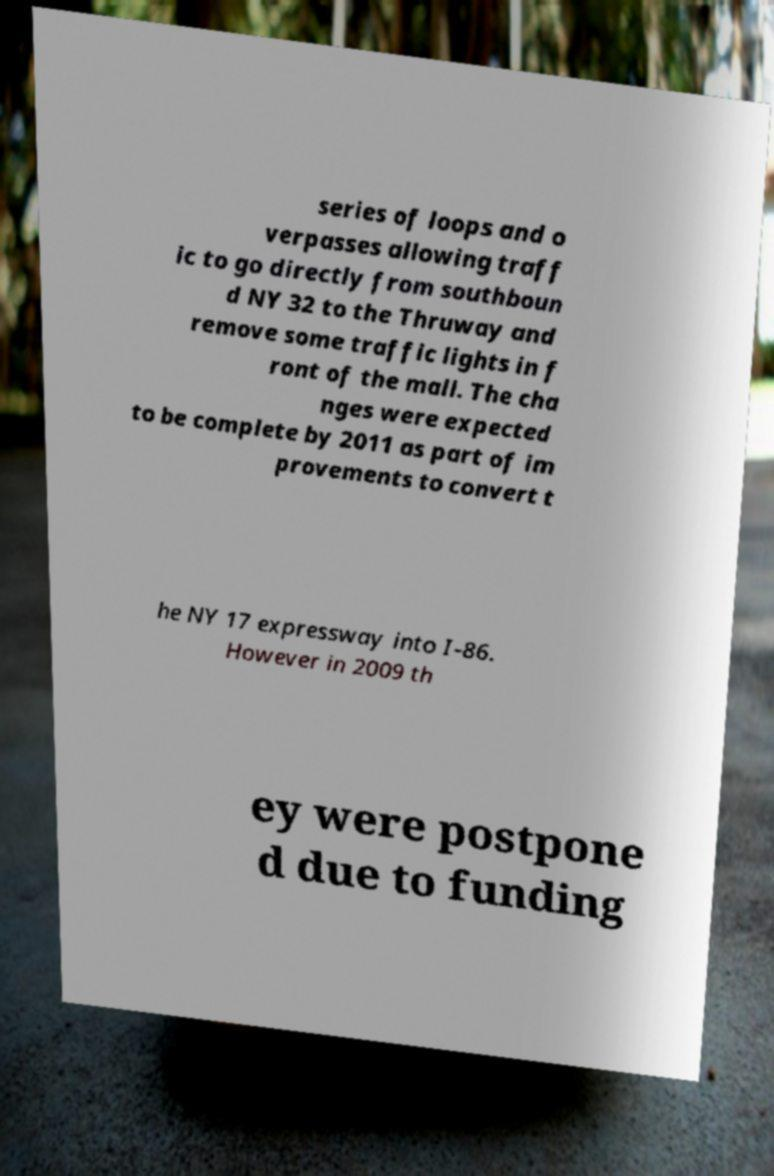What messages or text are displayed in this image? I need them in a readable, typed format. series of loops and o verpasses allowing traff ic to go directly from southboun d NY 32 to the Thruway and remove some traffic lights in f ront of the mall. The cha nges were expected to be complete by 2011 as part of im provements to convert t he NY 17 expressway into I-86. However in 2009 th ey were postpone d due to funding 